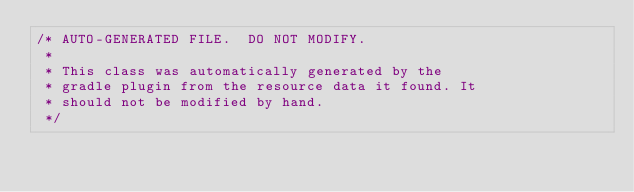<code> <loc_0><loc_0><loc_500><loc_500><_Java_>/* AUTO-GENERATED FILE.  DO NOT MODIFY.
 *
 * This class was automatically generated by the
 * gradle plugin from the resource data it found. It
 * should not be modified by hand.
 */</code> 